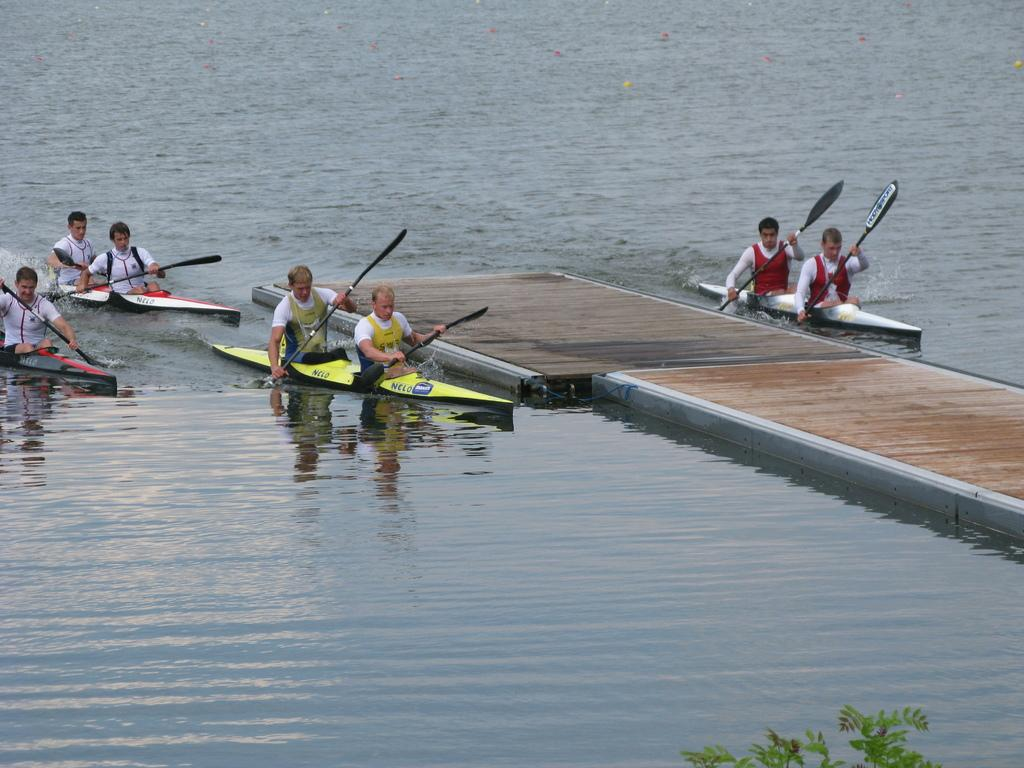What body of water is present in the image? There is a river in the image. What structure is built over the river? There is a bridge over the river. What activity is taking place in the river? There are people rowing in the river. What type of base is supporting the bridge in the image? There is no information provided about the base supporting the bridge in the image. What show is being performed on the bridge in the image? There is no show being performed on the bridge in the image; it is simply a structure for crossing the river. 